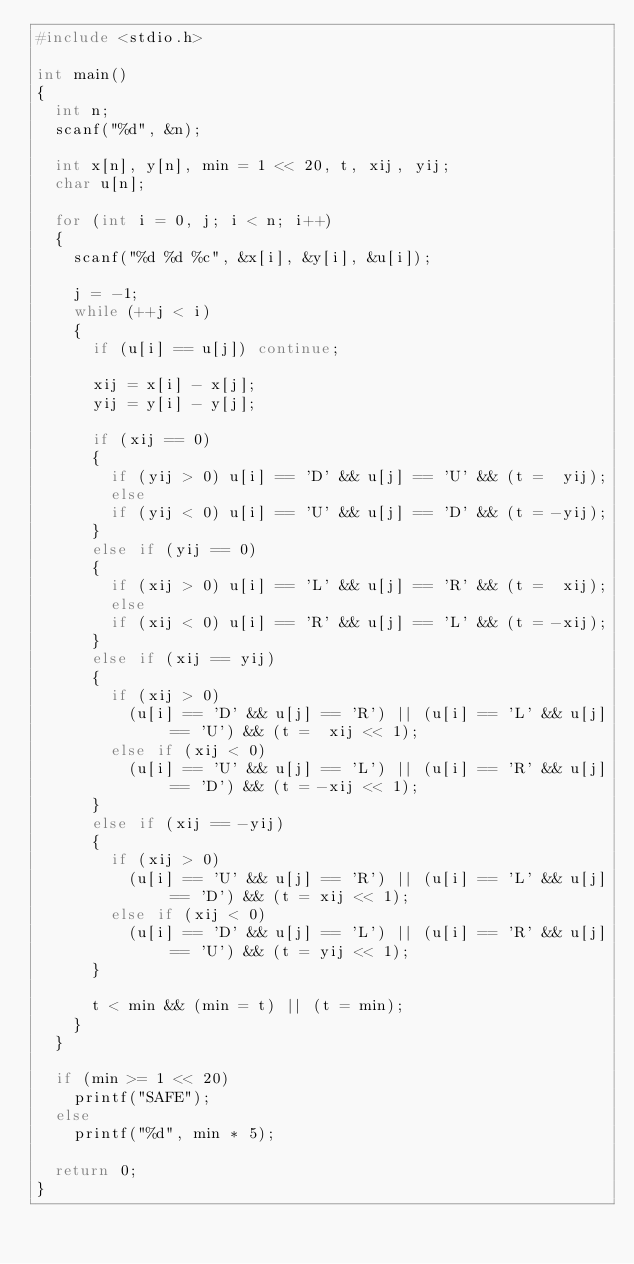Convert code to text. <code><loc_0><loc_0><loc_500><loc_500><_C_>#include <stdio.h>

int main()
{
  int n;
  scanf("%d", &n);
  
  int x[n], y[n], min = 1 << 20, t, xij, yij;
  char u[n];
	 
  for (int i = 0, j; i < n; i++)
  {
    scanf("%d %d %c", &x[i], &y[i], &u[i]);
    
    j = -1;
    while (++j < i)
    {
      if (u[i] == u[j]) continue;
      
      xij = x[i] - x[j];
      yij = y[i] - y[j];
      
      if (xij == 0)
      {
        if (yij > 0) u[i] == 'D' && u[j] == 'U' && (t =  yij);
        else 
        if (yij < 0) u[i] == 'U' && u[j] == 'D' && (t = -yij);
      }
      else if (yij == 0)
      {
        if (xij > 0) u[i] == 'L' && u[j] == 'R' && (t =  xij);
        else 
        if (xij < 0) u[i] == 'R' && u[j] == 'L' && (t = -xij);
      }
      else if (xij == yij)
      {
        if (xij > 0) 
          (u[i] == 'D' && u[j] == 'R') || (u[i] == 'L' && u[j] == 'U') && (t =  xij << 1);
        else if (xij < 0)
          (u[i] == 'U' && u[j] == 'L') || (u[i] == 'R' && u[j] == 'D') && (t = -xij << 1);
      }
      else if (xij == -yij)
      {
        if (xij > 0) 
          (u[i] == 'U' && u[j] == 'R') || (u[i] == 'L' && u[j] == 'D') && (t = xij << 1);
        else if (xij < 0) 
          (u[i] == 'D' && u[j] == 'L') || (u[i] == 'R' && u[j] == 'U') && (t = yij << 1);
      }
             
      t < min && (min = t) || (t = min);
    }
  }
  
  if (min >= 1 << 20)
    printf("SAFE");
  else
    printf("%d", min * 5);
  
  return 0;
}
</code> 